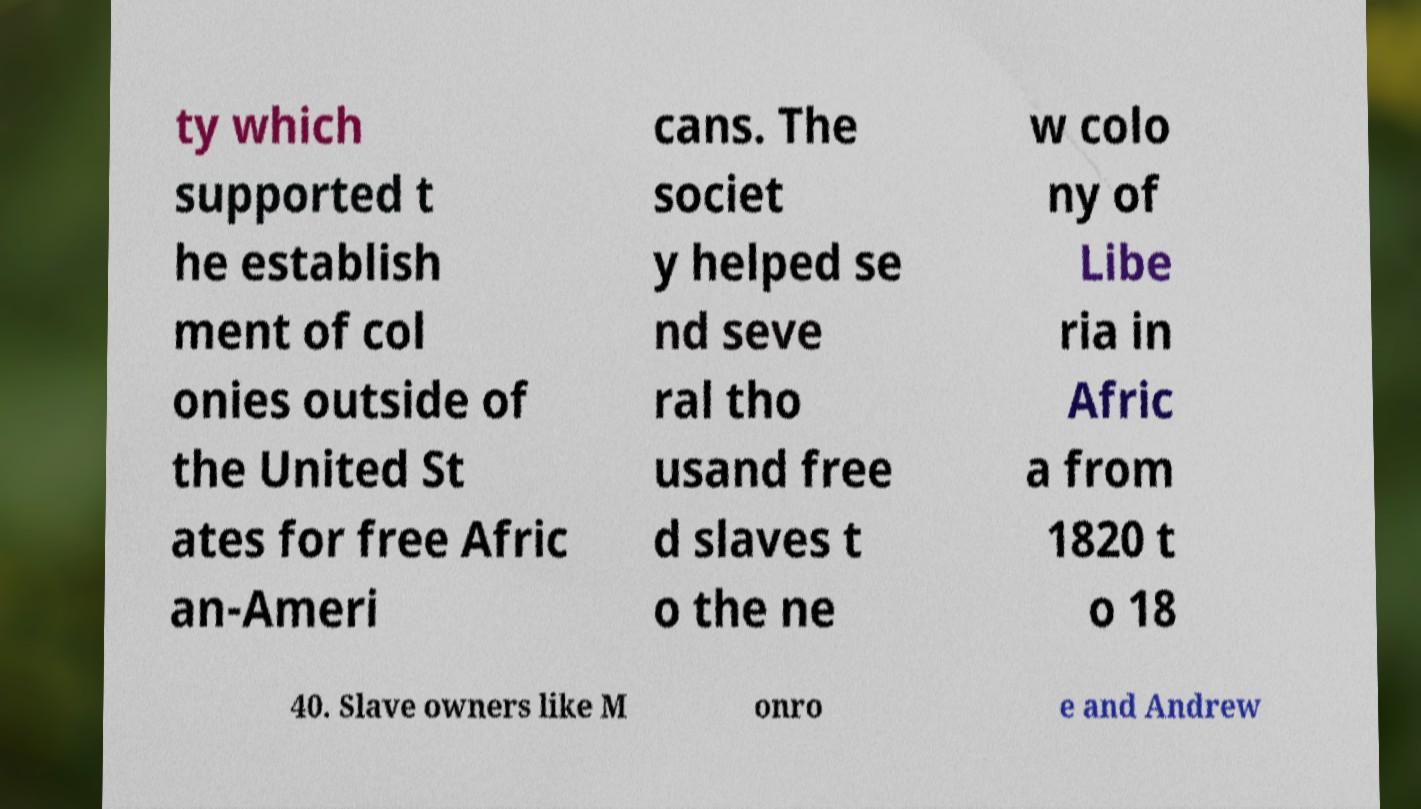Could you extract and type out the text from this image? ty which supported t he establish ment of col onies outside of the United St ates for free Afric an-Ameri cans. The societ y helped se nd seve ral tho usand free d slaves t o the ne w colo ny of Libe ria in Afric a from 1820 t o 18 40. Slave owners like M onro e and Andrew 